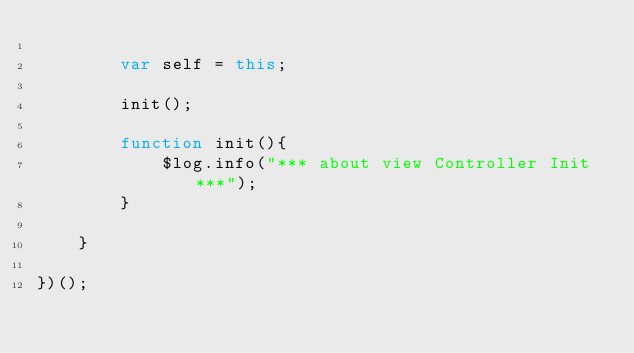Convert code to text. <code><loc_0><loc_0><loc_500><loc_500><_JavaScript_>
        var self = this;
        
        init();

        function init(){
        	$log.info("*** about view Controller Init ***");
        }

    }

})();</code> 